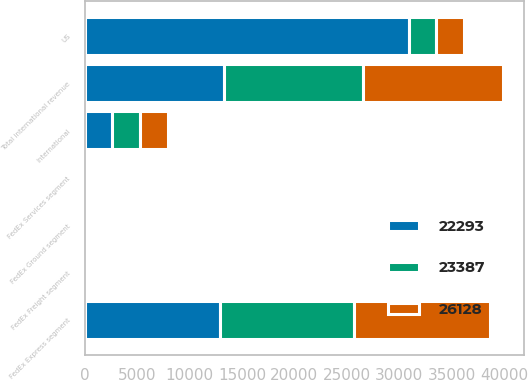Convert chart to OTSL. <chart><loc_0><loc_0><loc_500><loc_500><stacked_bar_chart><ecel><fcel>US<fcel>FedEx Express segment<fcel>FedEx Ground segment<fcel>FedEx Freight segment<fcel>FedEx Services segment<fcel>Total international revenue<fcel>International<nl><fcel>23387<fcel>2614<fcel>12772<fcel>311<fcel>142<fcel>12<fcel>13237<fcel>2614<nl><fcel>26128<fcel>2614<fcel>12916<fcel>248<fcel>130<fcel>14<fcel>13308<fcel>2729<nl><fcel>22293<fcel>30948<fcel>12959<fcel>234<fcel>112<fcel>34<fcel>13339<fcel>2656<nl></chart> 